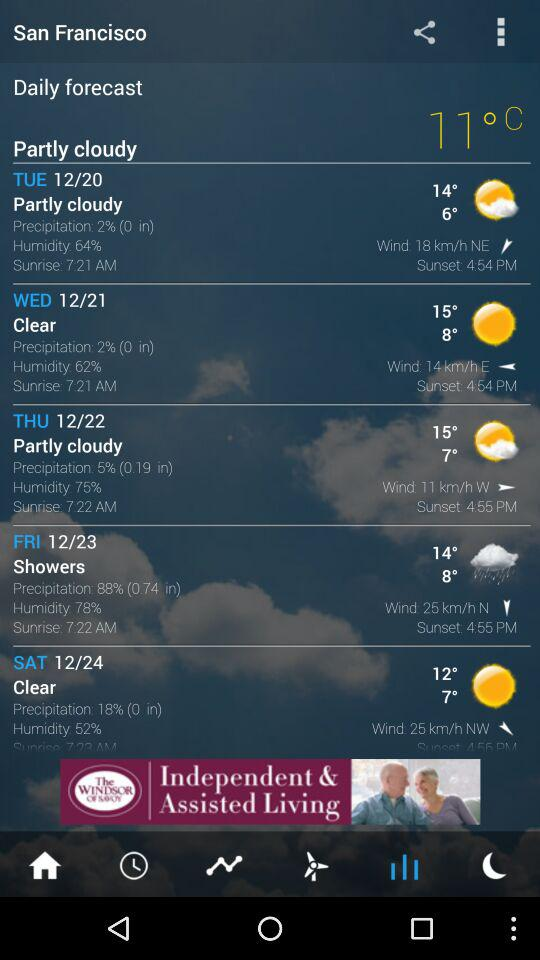What is the minimum temperature on Tuesday? The minimum temperature on Tuesday is 6°. 